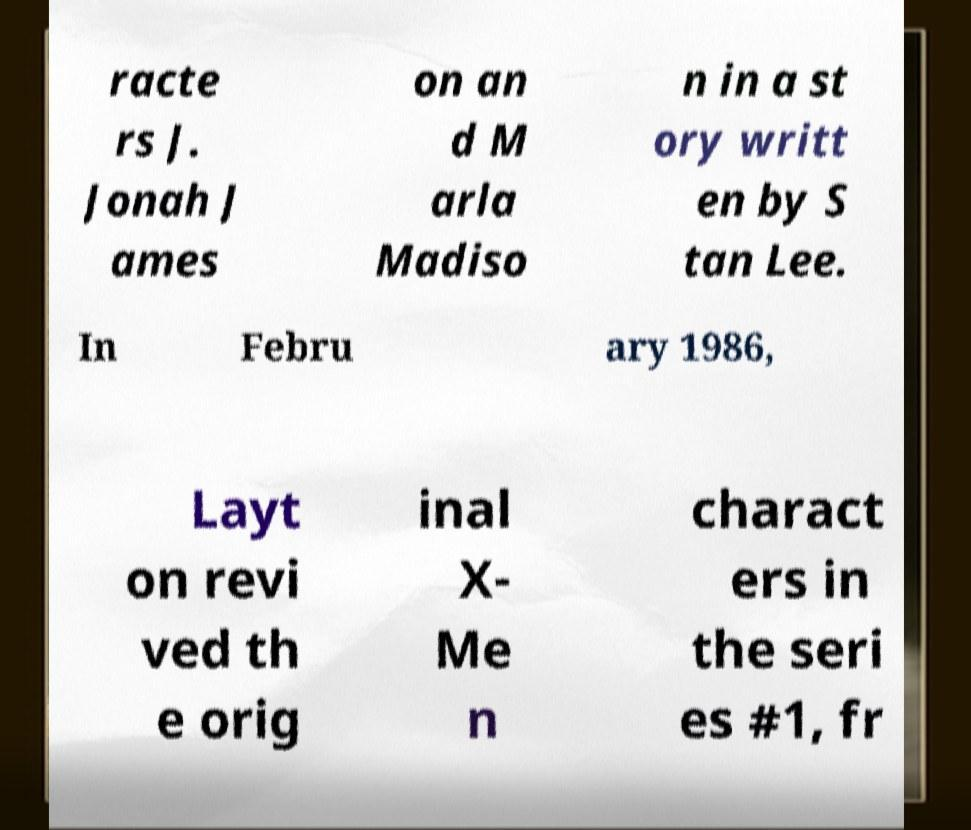Please read and relay the text visible in this image. What does it say? racte rs J. Jonah J ames on an d M arla Madiso n in a st ory writt en by S tan Lee. In Febru ary 1986, Layt on revi ved th e orig inal X- Me n charact ers in the seri es #1, fr 